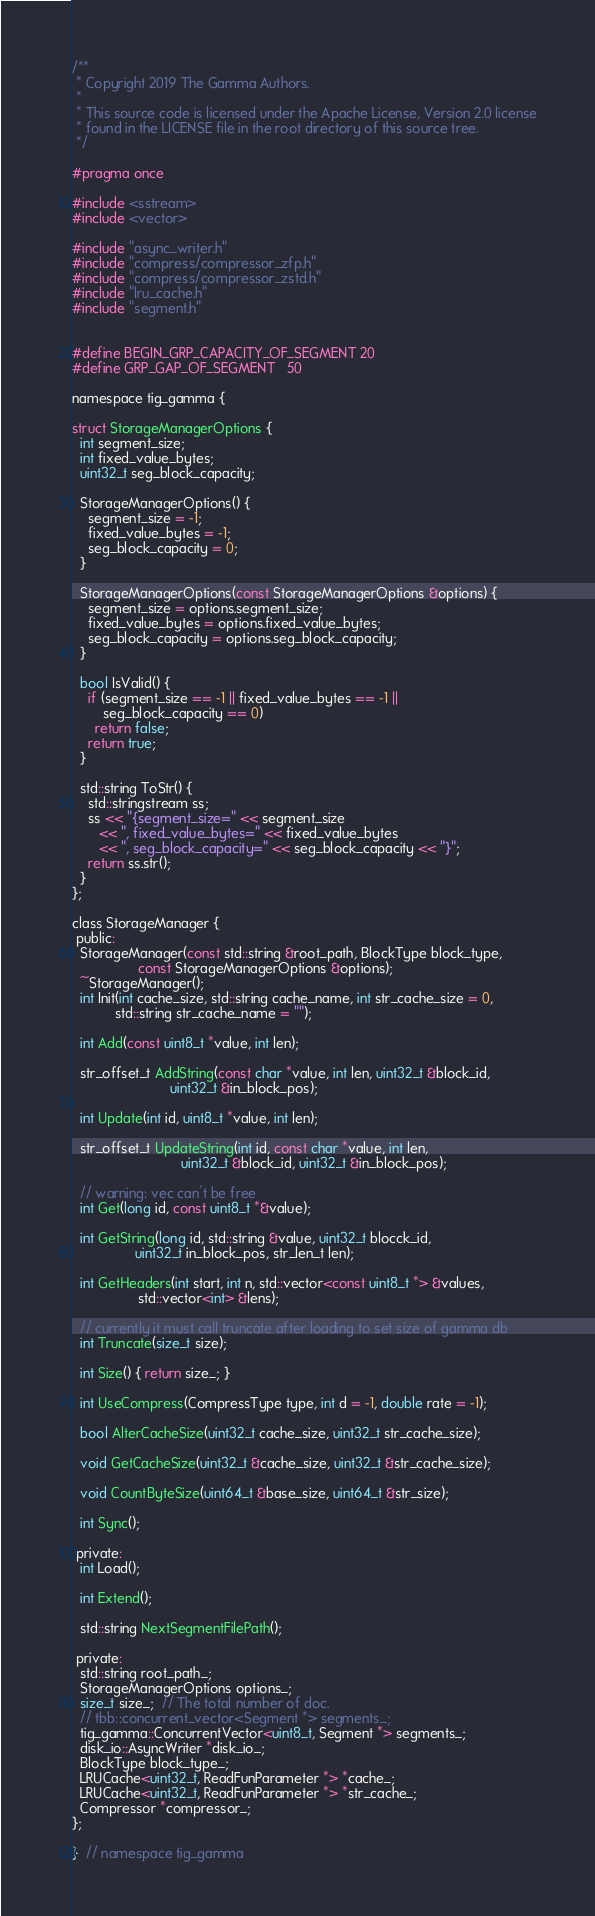<code> <loc_0><loc_0><loc_500><loc_500><_C_>/**
 * Copyright 2019 The Gamma Authors.
 *
 * This source code is licensed under the Apache License, Version 2.0 license
 * found in the LICENSE file in the root directory of this source tree.
 */

#pragma once

#include <sstream>
#include <vector>

#include "async_writer.h"
#include "compress/compressor_zfp.h"
#include "compress/compressor_zstd.h"
#include "lru_cache.h"
#include "segment.h"


#define BEGIN_GRP_CAPACITY_OF_SEGMENT 20
#define GRP_GAP_OF_SEGMENT   50

namespace tig_gamma {

struct StorageManagerOptions {
  int segment_size;
  int fixed_value_bytes;
  uint32_t seg_block_capacity;

  StorageManagerOptions() {
    segment_size = -1;
    fixed_value_bytes = -1;
    seg_block_capacity = 0;
  }

  StorageManagerOptions(const StorageManagerOptions &options) {
    segment_size = options.segment_size;
    fixed_value_bytes = options.fixed_value_bytes;
    seg_block_capacity = options.seg_block_capacity;
  }

  bool IsValid() {
    if (segment_size == -1 || fixed_value_bytes == -1 ||
        seg_block_capacity == 0)
      return false;
    return true;
  }

  std::string ToStr() {
    std::stringstream ss;
    ss << "{segment_size=" << segment_size
       << ", fixed_value_bytes=" << fixed_value_bytes
       << ", seg_block_capacity=" << seg_block_capacity << "}";
    return ss.str();
  }
};

class StorageManager {
 public:
  StorageManager(const std::string &root_path, BlockType block_type,
                 const StorageManagerOptions &options);
  ~StorageManager();
  int Init(int cache_size, std::string cache_name, int str_cache_size = 0,
           std::string str_cache_name = "");

  int Add(const uint8_t *value, int len);

  str_offset_t AddString(const char *value, int len, uint32_t &block_id,
                         uint32_t &in_block_pos);

  int Update(int id, uint8_t *value, int len);

  str_offset_t UpdateString(int id, const char *value, int len,
                            uint32_t &block_id, uint32_t &in_block_pos);

  // warning: vec can't be free
  int Get(long id, const uint8_t *&value);

  int GetString(long id, std::string &value, uint32_t blocck_id,
                uint32_t in_block_pos, str_len_t len);

  int GetHeaders(int start, int n, std::vector<const uint8_t *> &values,
                 std::vector<int> &lens);

  // currently it must call truncate after loading to set size of gamma db
  int Truncate(size_t size);

  int Size() { return size_; }

  int UseCompress(CompressType type, int d = -1, double rate = -1);

  bool AlterCacheSize(uint32_t cache_size, uint32_t str_cache_size);

  void GetCacheSize(uint32_t &cache_size, uint32_t &str_cache_size);

  void CountByteSize(uint64_t &base_size, uint64_t &str_size);

  int Sync();

 private:
  int Load();

  int Extend();

  std::string NextSegmentFilePath();

 private:
  std::string root_path_;
  StorageManagerOptions options_;
  size_t size_;  // The total number of doc.
  // tbb::concurrent_vector<Segment *> segments_;
  tig_gamma::ConcurrentVector<uint8_t, Segment *> segments_;
  disk_io::AsyncWriter *disk_io_;
  BlockType block_type_;
  LRUCache<uint32_t, ReadFunParameter *> *cache_;
  LRUCache<uint32_t, ReadFunParameter *> *str_cache_;
  Compressor *compressor_;
};

}  // namespace tig_gamma
</code> 